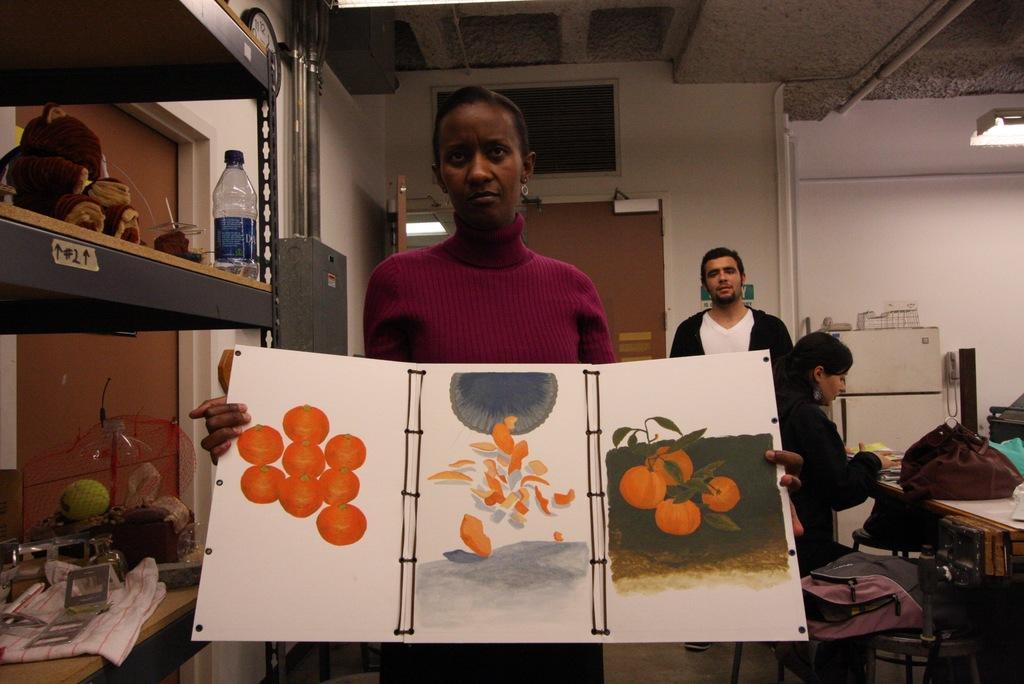In one or two sentences, can you explain what this image depicts? In this image the woman is holding a chart. There is a racks. At the back side there are two persons. On the table there is a bag. 